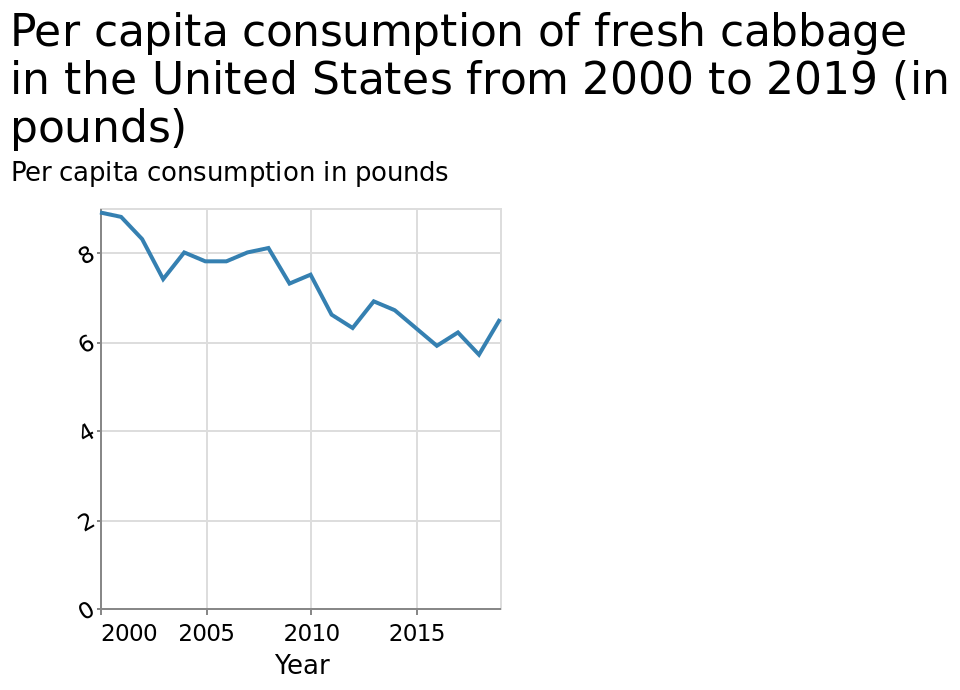<image>
What is the minimum year represented on the x-axis? The minimum year represented on the x-axis is 2000. please summary the statistics and relations of the chart Cabbage consumption has generally declined from 2000 to 2019, but there has been an increase in 2019. What has been the trend in cabbage consumption from 2000 to 2019?  Cabbage consumption has generally declined from 2000 to 2019. What is the maximum year represented on the x-axis? The maximum year represented on the x-axis is 2019. 